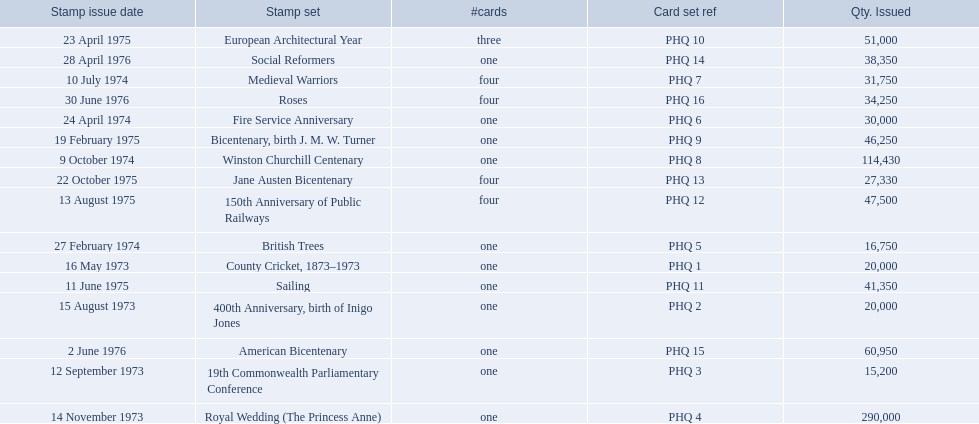Which stamp sets contained more than one card? Medieval Warriors, European Architectural Year, 150th Anniversary of Public Railways, Jane Austen Bicentenary, Roses. Of those stamp sets, which contains a unique number of cards? European Architectural Year. 